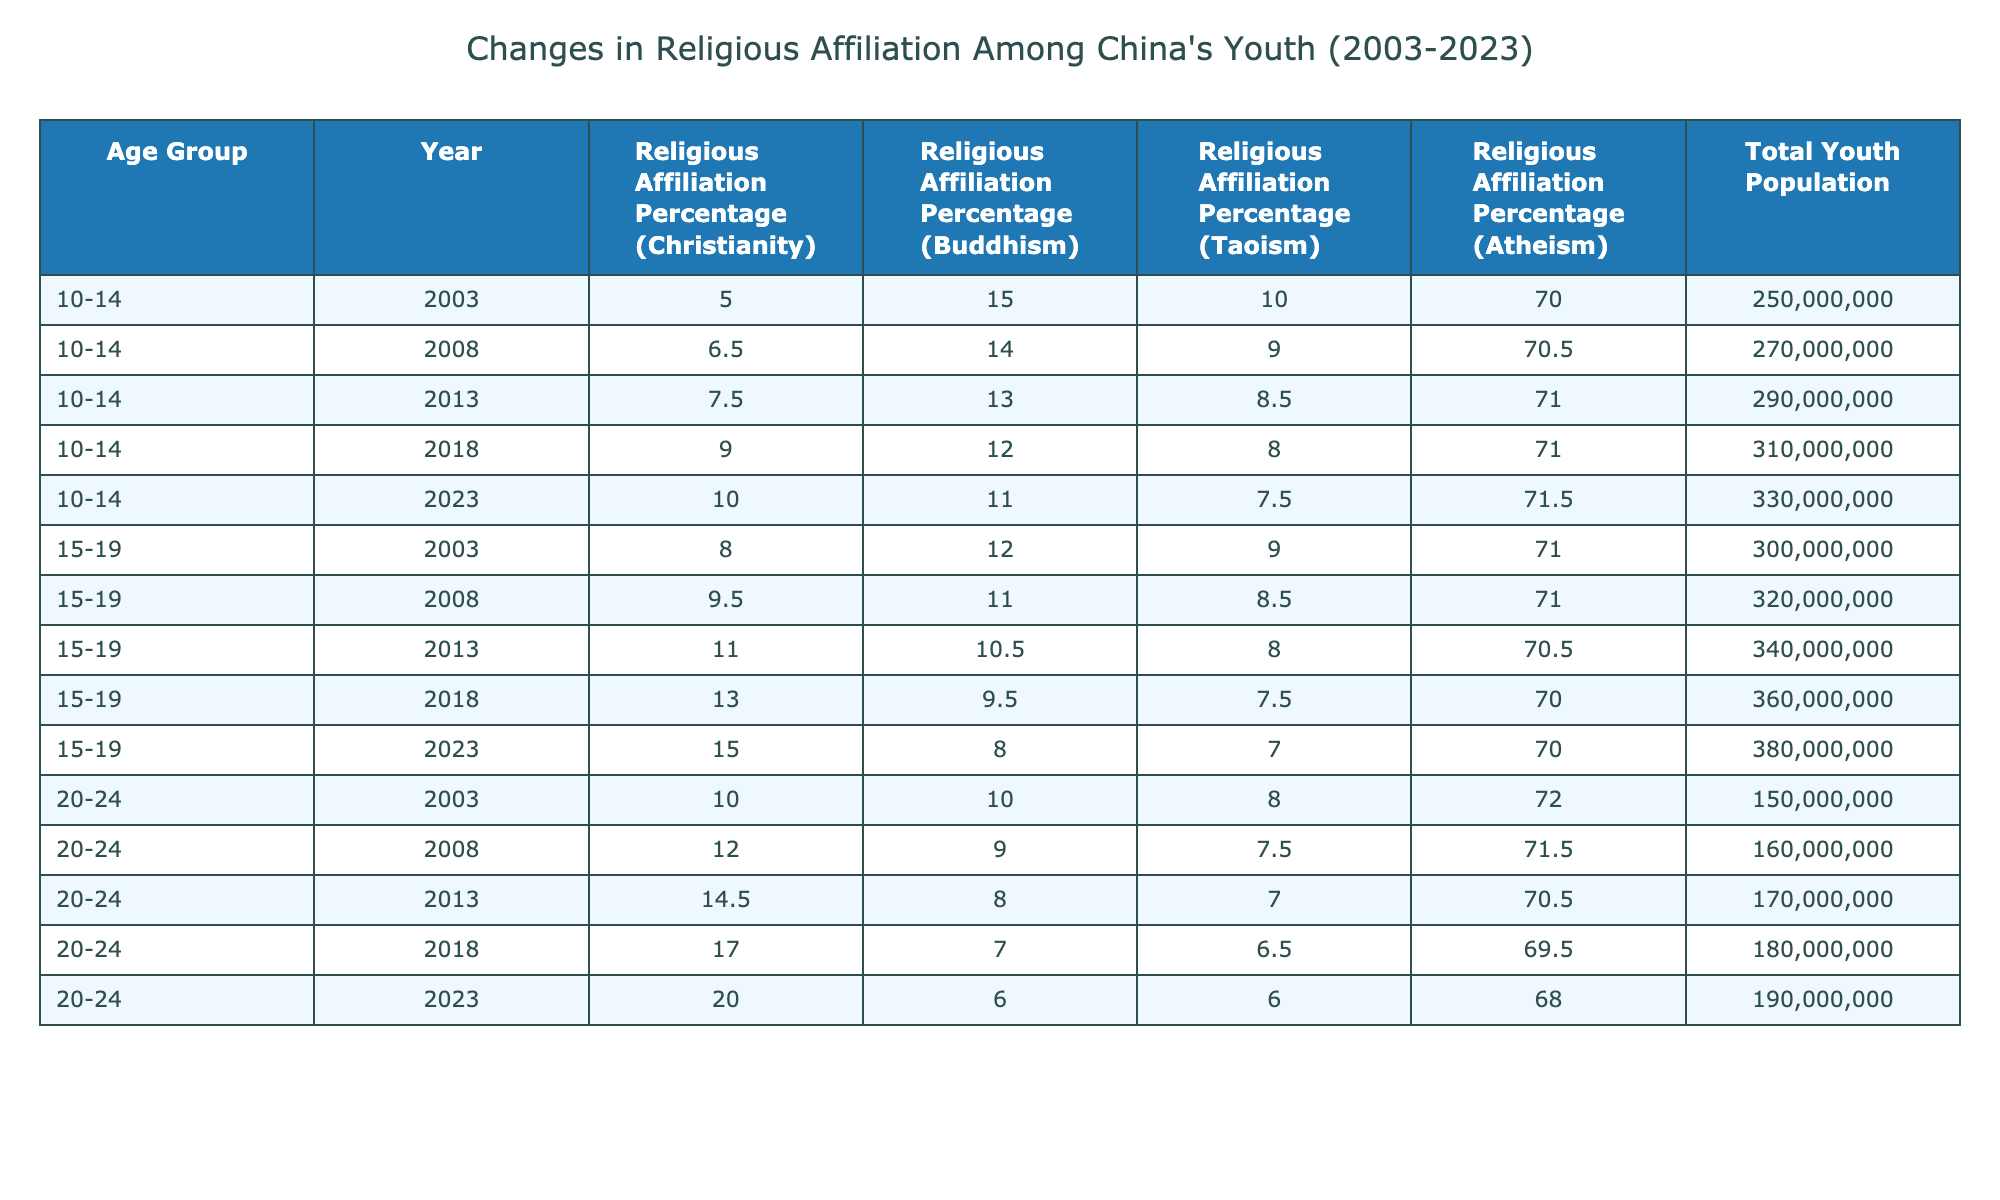What was the religious affiliation percentage for Christianity among the 10-14 age group in 2023? In the data, I will look for the row corresponding to the 10-14 age group in the year 2023. The table shows a percentage of 10.0 for Christianity in that row.
Answer: 10.0 How much did the percentage of Buddhism among 20-24 year-olds decrease from 2003 to 2023? First, I find the Buddhism percentage for the 20-24 age group in both 2003 (10.0) and 2023 (6.0). Then, I calculate the decrease: 10.0 - 6.0 = 4.0.
Answer: 4.0 Is the total youth population for the 15-19 age group higher in 2023 than in 2003? In 2023, the total youth population for this age group is 380,000,000, and in 2003 it was 300,000,000. Since 380,000,000 is greater than 300,000,000, the statement is true.
Answer: Yes What age group showed the highest percentage of atheism in 2018? I check the atheism percentages for each age group in 2018: 71.0% (10-14), 70.0% (15-19), and 69.5% (20-24). The highest percentage is 71.0% for the 10-14 age group.
Answer: 10-14 What was the average percentage of religious affiliation for Taoism across all age groups in 2023? I take the Taoism percentages for all age groups in 2023: 7.5 (10-14), 7.0 (15-19), and 6.0 (20-24). I sum them: 7.5 + 7.0 + 6.0 = 20.5, and divide by 3 (the number of groups): 20.5 / 3 = 6.83.
Answer: 6.83 Which age group had the largest increase in the percentage of Christian affiliation from 2003 to 2023? I look for the percentage increase for each age group: for 10-14 it’s 10.0 - 5.0 = 5.0, for 15-19 it’s 15.0 - 8.0 = 7.0, and for 20-24 it’s 20.0 - 10.0 = 10.0. The largest increase is 10.0 for the 20-24 age group.
Answer: 20-24 Was there a decline in the percentage of Buddhism among the 15-19 age group from 2013 to 2023? I compare the percentages: in 2013 it was 10.5% and in 2023 it’s 8.0%. Since 8.0% is lower than 10.5%, this indicates a decline.
Answer: Yes What is the total youth population for the 10-14 age group in 2018? The table indicates that in 2018, the total youth population for the 10-14 age group is 310,000,000.
Answer: 310000000 